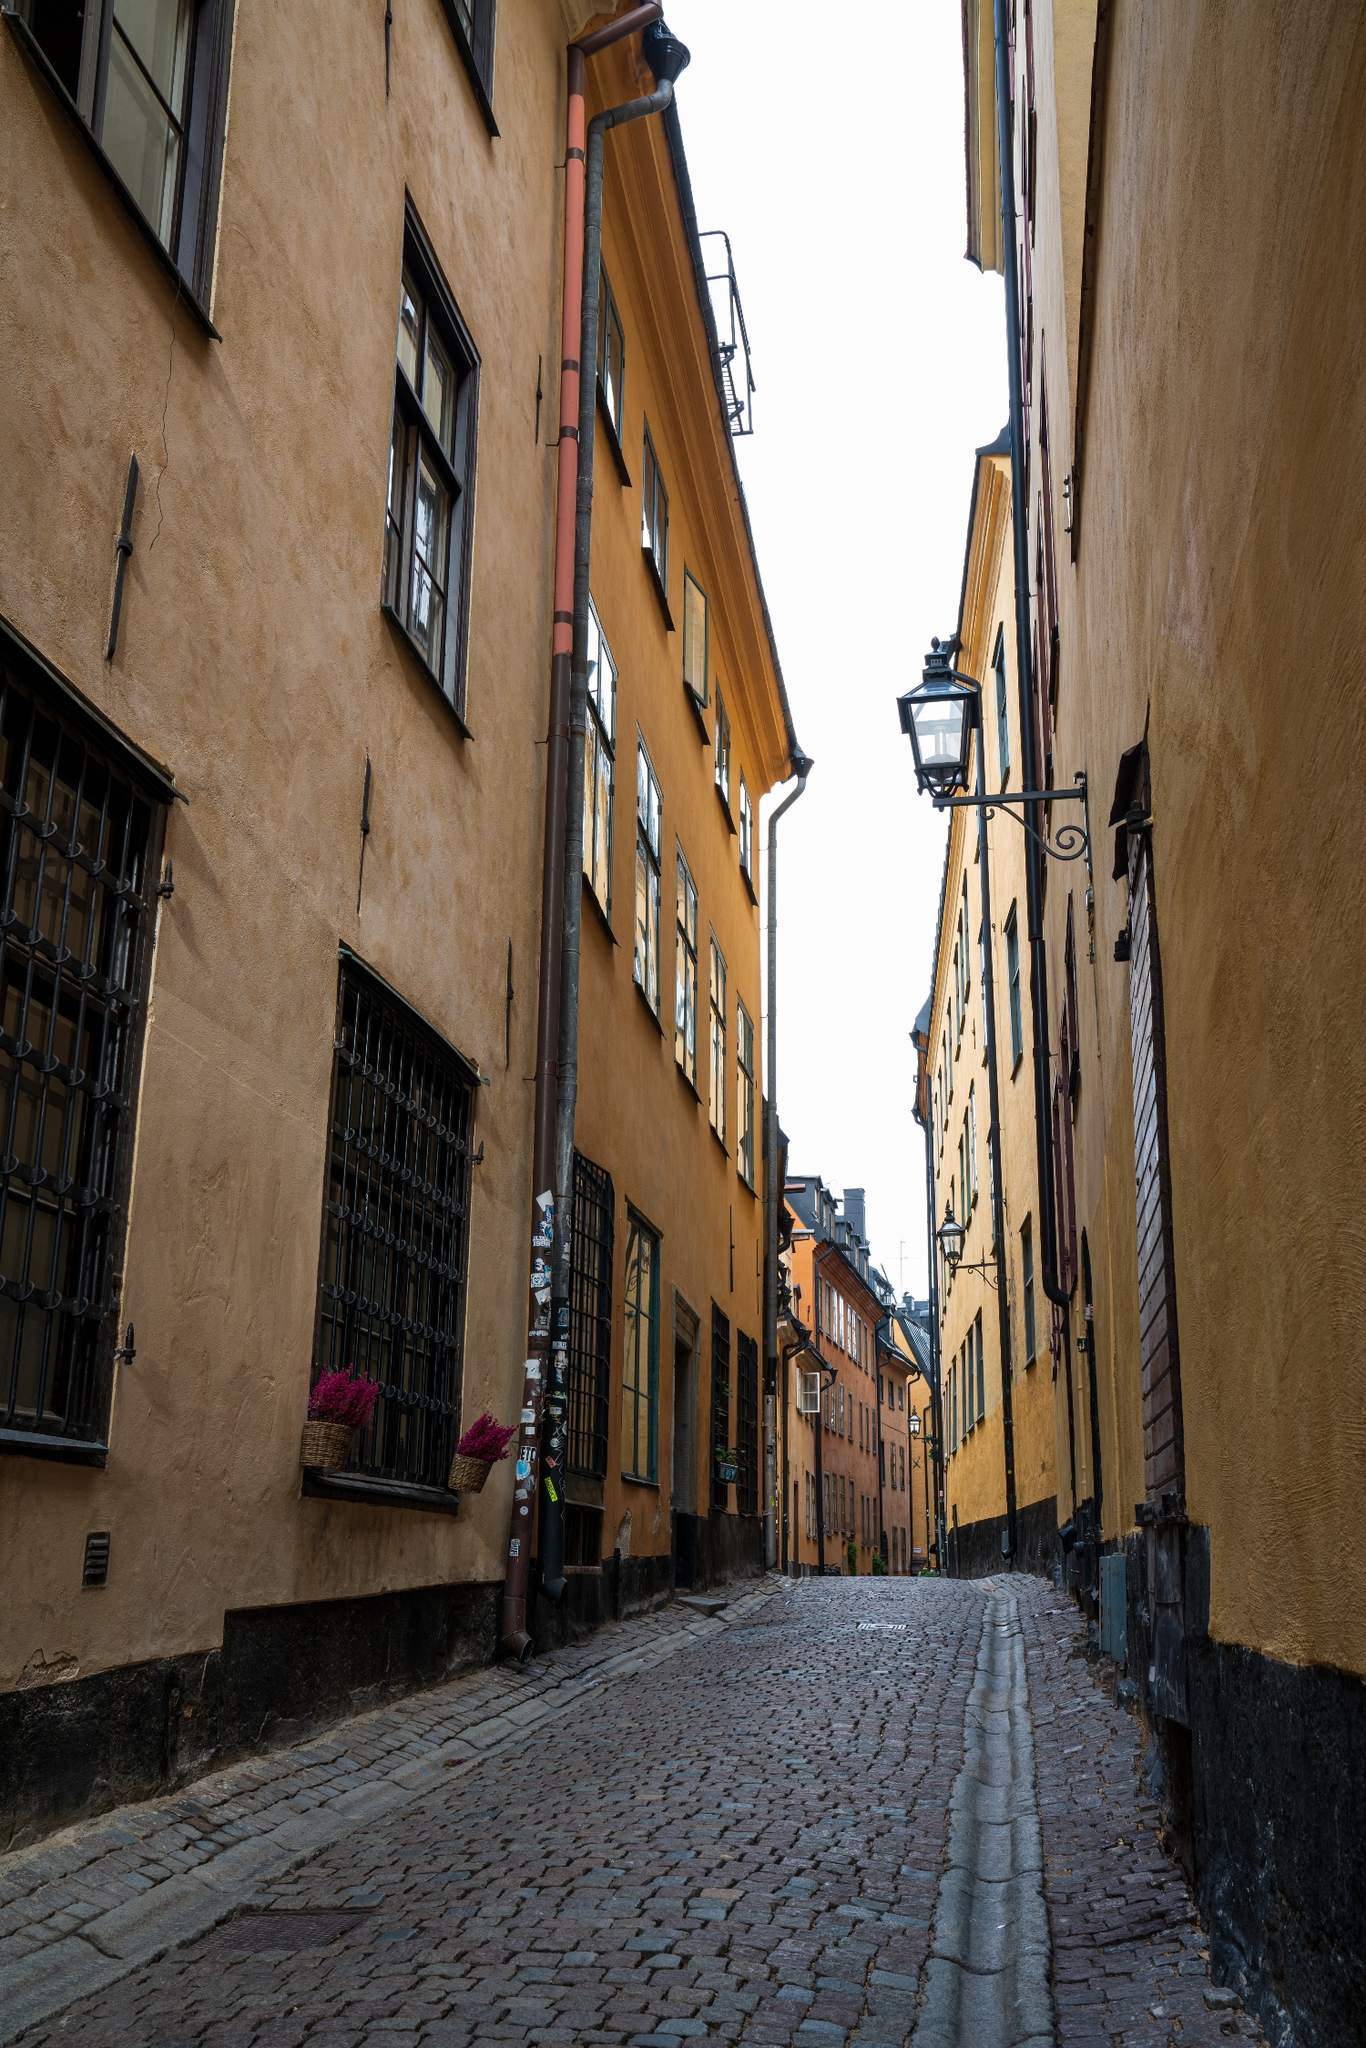Can you elaborate on the elements of the picture provided?
 The image captures a charming scene from the old town of Stockholm, Sweden. The viewer's eye is drawn down a narrow cobblestone street, flanked on both sides by tall buildings. These structures, painted in warm hues of yellow and orange, are punctuated by wooden shutters and flower boxes that add a touch of homeliness to the urban landscape. The perspective of the image is from the ground, looking up towards the end of the street, giving a sense of depth and inviting the viewer to imagine what lies beyond. The sky overhead is overcast, casting a diffused light that softens the colors and enhances the overall ambiance of the scene. Despite the absence of people, the image exudes a sense of life and vibrancy, a testament to the city's enduring charm. 